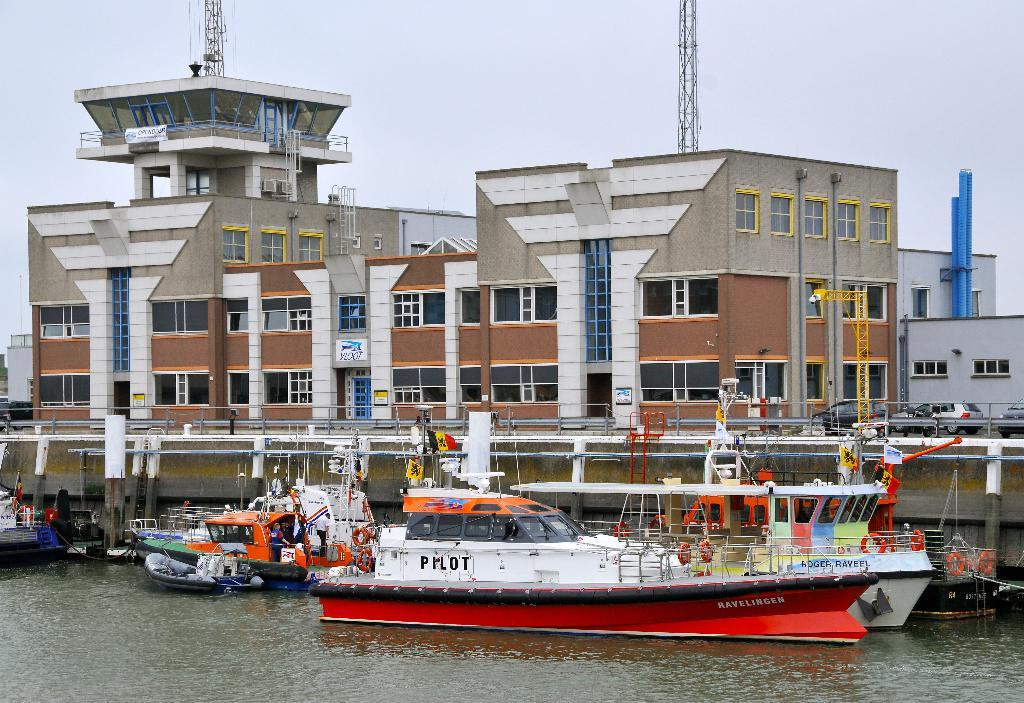What is located in the foreground of the image? There are boats and a ship in the foreground of the image. Where are the boats and ship situated? They are on the water. What can be seen in the background of the image? There are buildings, poles, and the sky visible in the background of the image. Can you describe any specific features of the boats or ship? There is railing visible in the image. What type of insurance policy is being discussed by the boats in the image? There are no discussions or insurance policies present in the image; it features boats and a ship on the water. Can you recite a verse from the poem that is being read by the ship in the image? There is no poem or reading taking place in the image; it simply shows boats and a ship on the water. 